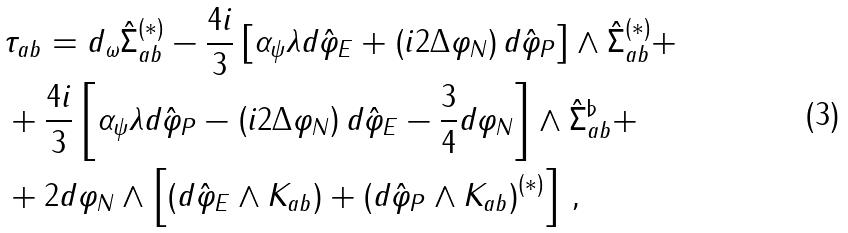Convert formula to latex. <formula><loc_0><loc_0><loc_500><loc_500>& \tau _ { a b } = d _ { \omega } \hat { \Sigma } ^ { ( * ) } _ { a b } - \frac { 4 i } { 3 } \left [ \alpha _ { \psi } \lambda d \hat { \varphi } _ { E } + \left ( i 2 \Delta \varphi _ { N } \right ) d \hat { \varphi } _ { P } \right ] \wedge \hat { \Sigma } ^ { ( * ) } _ { a b } + \\ & + \frac { 4 i } { 3 } \left [ \alpha _ { \psi } \lambda d \hat { \varphi } _ { P } - \left ( i 2 \Delta \varphi _ { N } \right ) d \hat { \varphi } _ { E } - \frac { 3 } { 4 } d \varphi _ { N } \right ] \wedge \hat { \Sigma } ^ { \flat } _ { a b } + \\ & + 2 d \varphi _ { N } \wedge \left [ \left ( d \hat { \varphi } _ { E } \wedge K _ { a b } \right ) + \left ( d \hat { \varphi } _ { P } \wedge K _ { a b } \right ) ^ { ( * ) } \right ] \, ,</formula> 